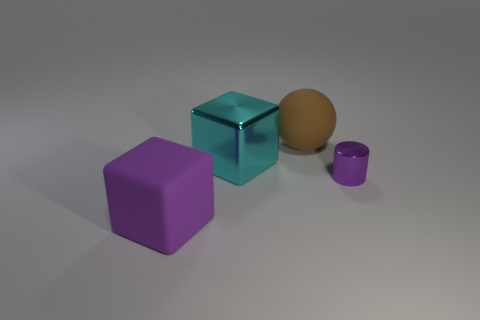Subtract 1 cubes. How many cubes are left? 1 Add 4 large red metal balls. How many objects exist? 8 Subtract all yellow blocks. Subtract all green cylinders. How many blocks are left? 2 Subtract all cyan blocks. Subtract all large purple matte cubes. How many objects are left? 2 Add 4 tiny objects. How many tiny objects are left? 5 Add 2 metallic cubes. How many metallic cubes exist? 3 Subtract 0 blue cylinders. How many objects are left? 4 Subtract all spheres. How many objects are left? 3 